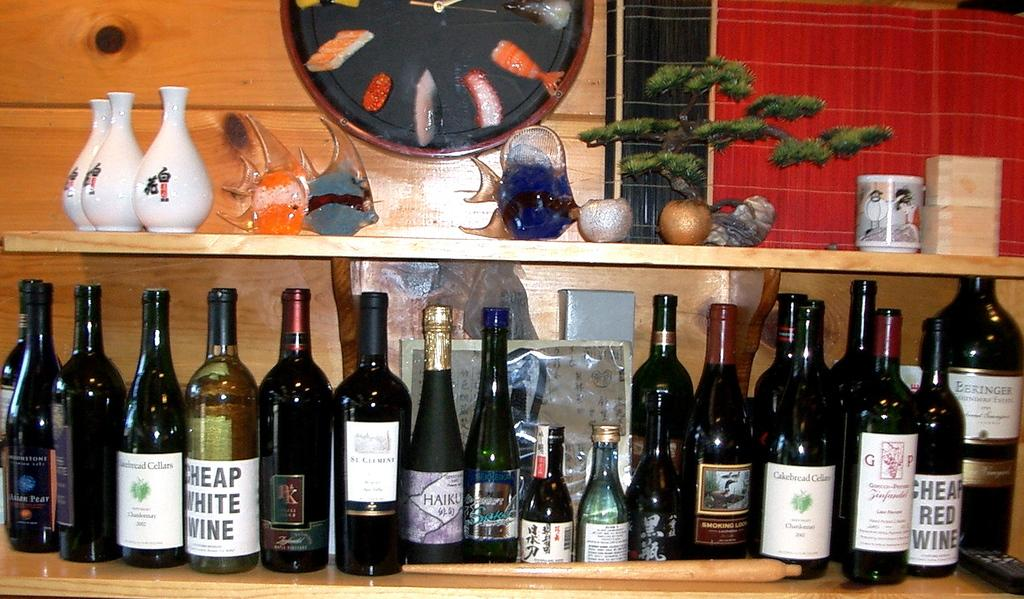Provide a one-sentence caption for the provided image. Several bottles of alcohol, including Cheap White Wine, on the shelf below some ceramic mugs and fish figures. 